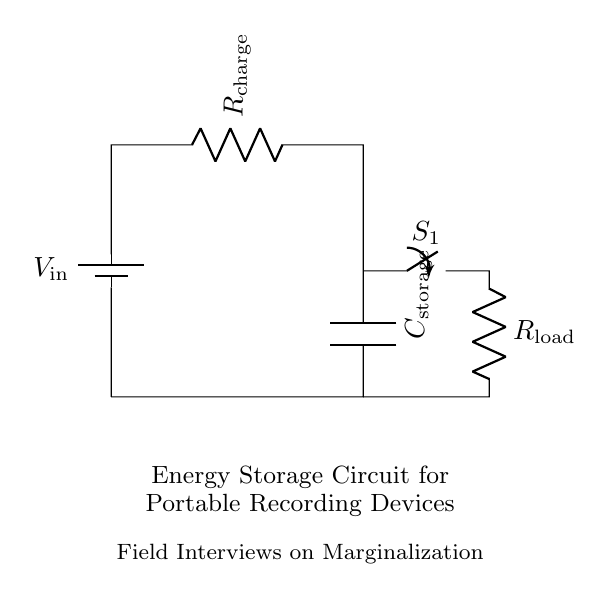What is the storage component in this circuit? The storage component is the capacitor, labeled as C_storage, which is used to store electric energy for later use.
Answer: C_storage What is the function of the switch in this circuit? The switch, labeled as S_1, can open or close the circuit, controlling the flow of current to the load resistor based on whether it is in the on or off position.
Answer: Control current flow What happens to the capacitor when the circuit is closed? Closing the switch S_1 allows current to flow from the capacitor through the load resistor, discharging the stored energy in the capacitor to power the device.
Answer: Capacitor discharges What is the role of the resistor labeled R_charge? The resistor R_charge is placed in series with the input voltage to limit the current flowing into the capacitor during the charging phase, preventing damage to the capacitor.
Answer: Current limiting How does the capacitor influence the circuit's performance during field interviews? The capacitor provides a reliable energy source that maintains power for recording devices during field interviews, especially important in areas with unstable power supply.
Answer: Energy reliability What would happen if the capacitor were removed from the circuit? Removing the capacitor would lead to a loss of energy storage capability, causing the recording device to run directly off the battery, which could result in power fluctuations and interruptions.
Answer: Loss of energy storage 